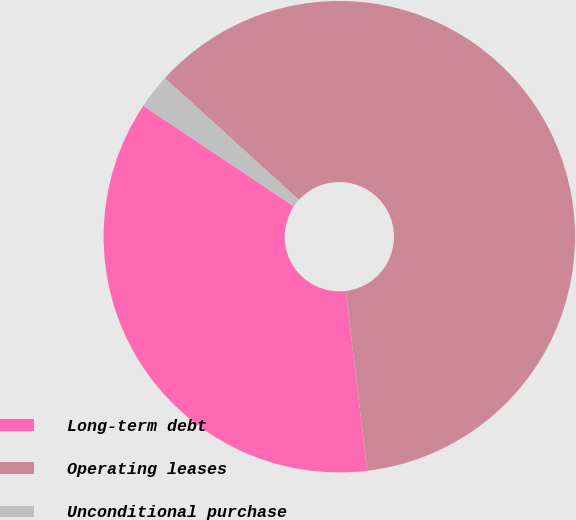Convert chart to OTSL. <chart><loc_0><loc_0><loc_500><loc_500><pie_chart><fcel>Long-term debt<fcel>Operating leases<fcel>Unconditional purchase<nl><fcel>36.26%<fcel>61.37%<fcel>2.37%<nl></chart> 